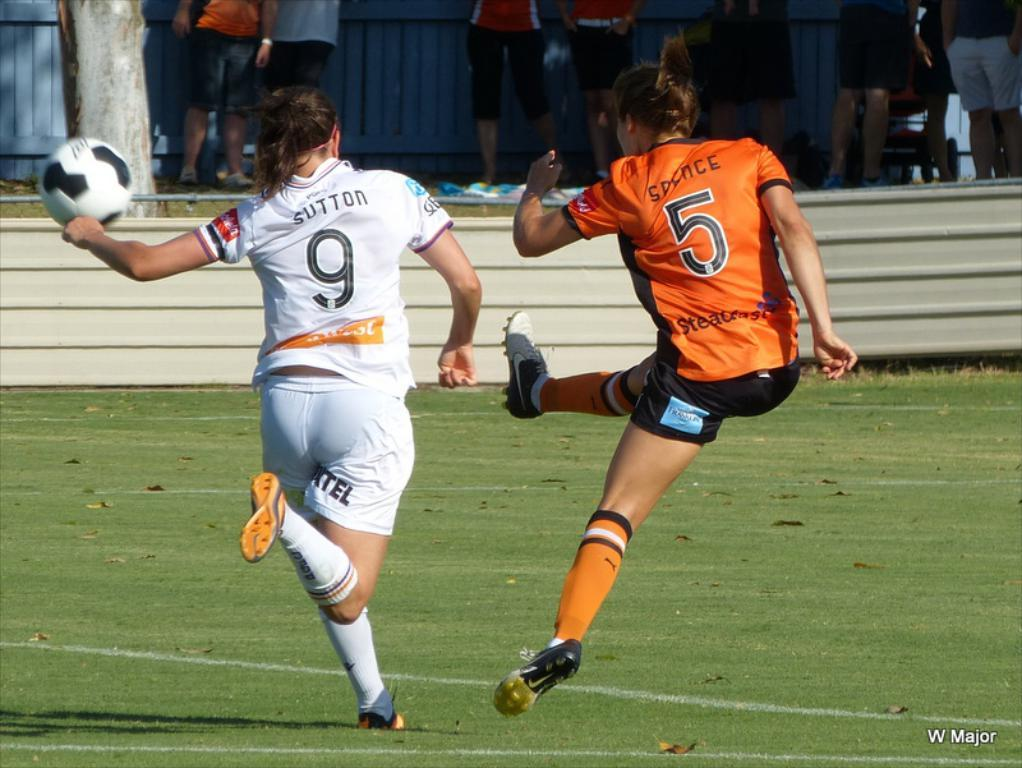<image>
Summarize the visual content of the image. A female soccer player in white with Sutton 9 on her jersey chases a ball kicked by a player in an orange jersey with the number 5 on it. 